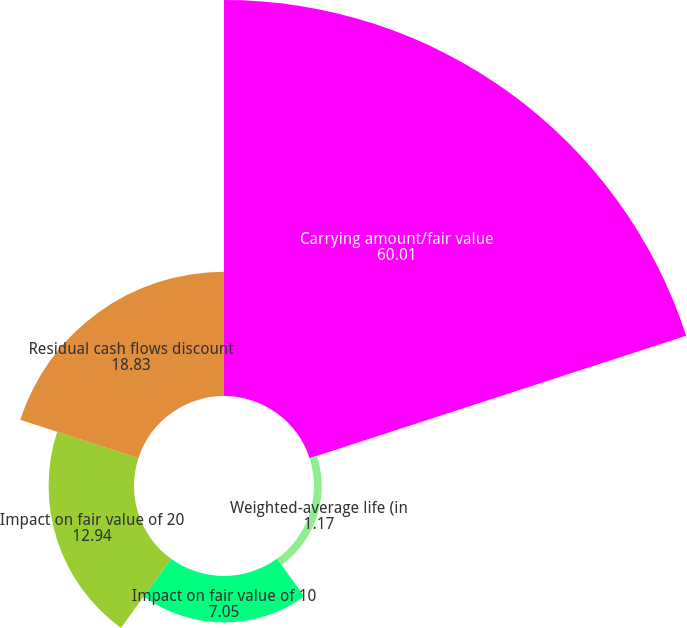<chart> <loc_0><loc_0><loc_500><loc_500><pie_chart><fcel>Carrying amount/fair value<fcel>Weighted-average life (in<fcel>Impact on fair value of 10<fcel>Impact on fair value of 20<fcel>Residual cash flows discount<nl><fcel>60.01%<fcel>1.17%<fcel>7.05%<fcel>12.94%<fcel>18.83%<nl></chart> 